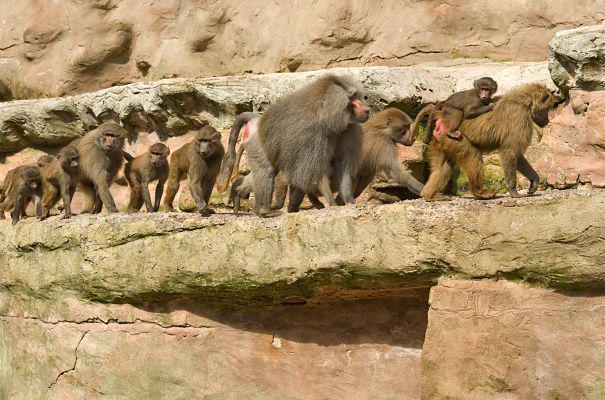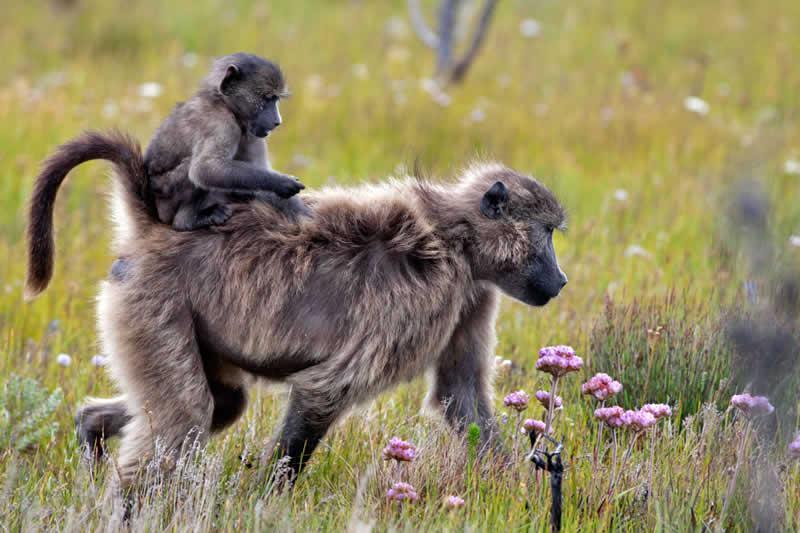The first image is the image on the left, the second image is the image on the right. Examine the images to the left and right. Is the description "One image has no more than 7 baboons." accurate? Answer yes or no. Yes. The first image is the image on the left, the second image is the image on the right. Given the left and right images, does the statement "The right image shows a large group of animals on a road." hold true? Answer yes or no. No. 